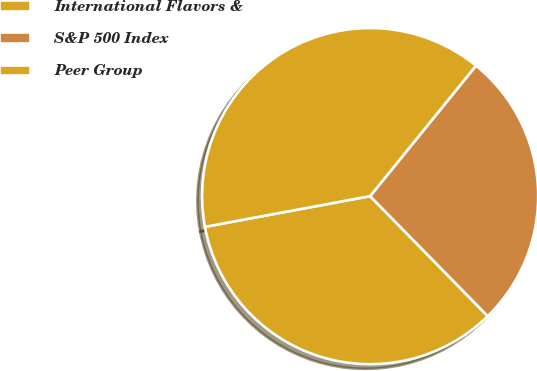Convert chart to OTSL. <chart><loc_0><loc_0><loc_500><loc_500><pie_chart><fcel>International Flavors &<fcel>S&P 500 Index<fcel>Peer Group<nl><fcel>34.41%<fcel>26.81%<fcel>38.78%<nl></chart> 